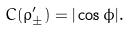Convert formula to latex. <formula><loc_0><loc_0><loc_500><loc_500>C ( \rho _ { \pm } ^ { \prime } ) = | \cos \phi | .</formula> 